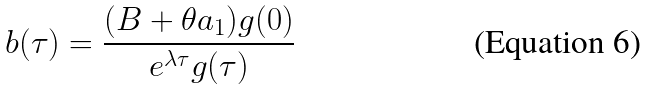Convert formula to latex. <formula><loc_0><loc_0><loc_500><loc_500>b ( \tau ) = \frac { ( B + \theta a _ { 1 } ) g ( 0 ) } { e ^ { \lambda \tau } g ( \tau ) }</formula> 